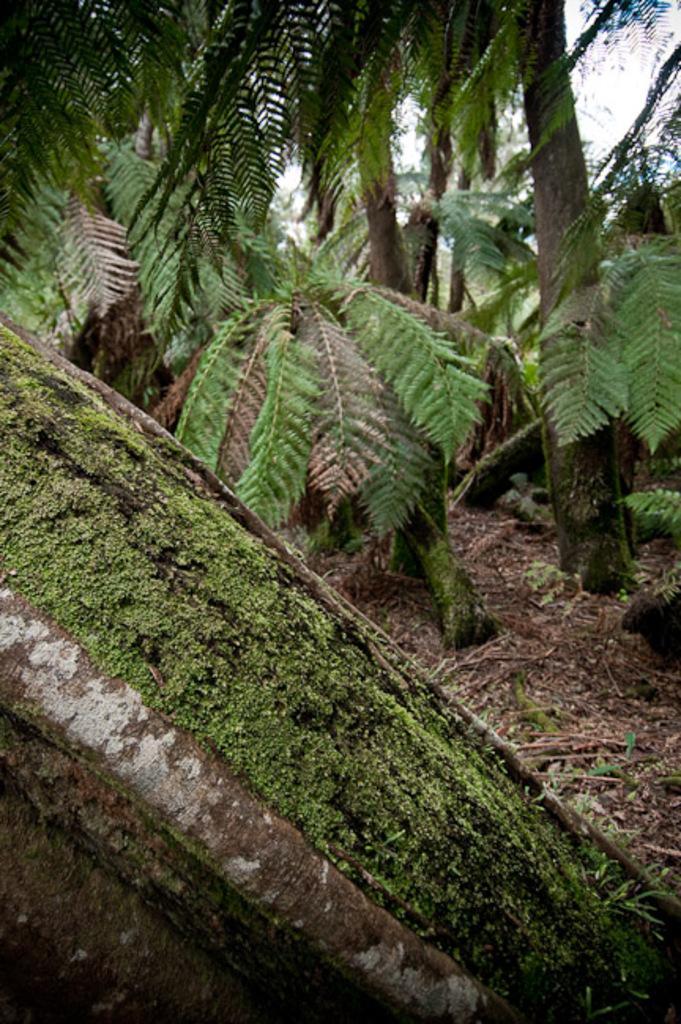Please provide a concise description of this image. There is a stem of a tree at the bottom of this image and there are some other trees in the background. 